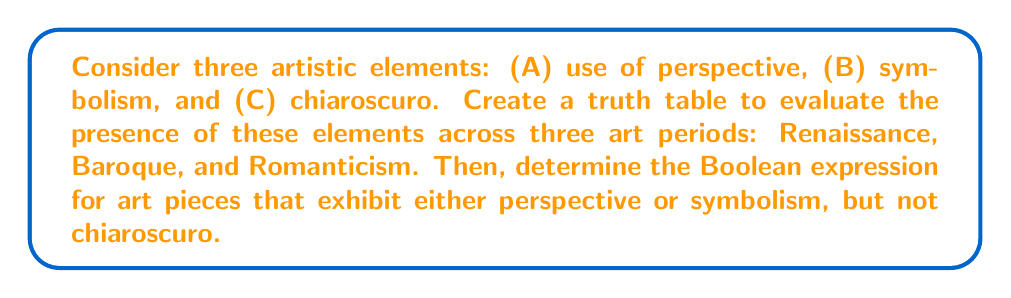Show me your answer to this math problem. Step 1: Create the truth table for the given artistic elements across the three periods.

$$
\begin{array}{|c|c|c|c|}
\hline
\text{Period} & A & B & C \\
\hline
\text{Renaissance} & 1 & 1 & 1 \\
\text{Baroque} & 1 & 1 & 1 \\
\text{Romanticism} & 0 & 1 & 0 \\
\hline
\end{array}
$$

Step 2: We need to find the Boolean expression for art pieces that exhibit either perspective (A) or symbolism (B), but not chiaroscuro (C). This can be represented as:

$$(A \lor B) \land \lnot C$$

Step 3: Evaluate this expression for each period:

Renaissance: $(1 \lor 1) \land \lnot 1 = 1 \land 0 = 0$
Baroque: $(1 \lor 1) \land \lnot 1 = 1 \land 0 = 0$
Romanticism: $(0 \lor 1) \land \lnot 0 = 1 \land 1 = 1$

Step 4: The resulting truth table for our expression is:

$$
\begin{array}{|c|c|}
\hline
\text{Period} & (A \lor B) \land \lnot C \\
\hline
\text{Renaissance} & 0 \\
\text{Baroque} & 0 \\
\text{Romanticism} & 1 \\
\hline
\end{array}
$$

Step 5: The Boolean expression $(A \lor B) \land \lnot C$ is true only for the Romanticism period, which aligns with the historical understanding that Romantic art often used symbolism but moved away from strict perspective and chiaroscuro techniques.
Answer: $(A \lor B) \land \lnot C$ 